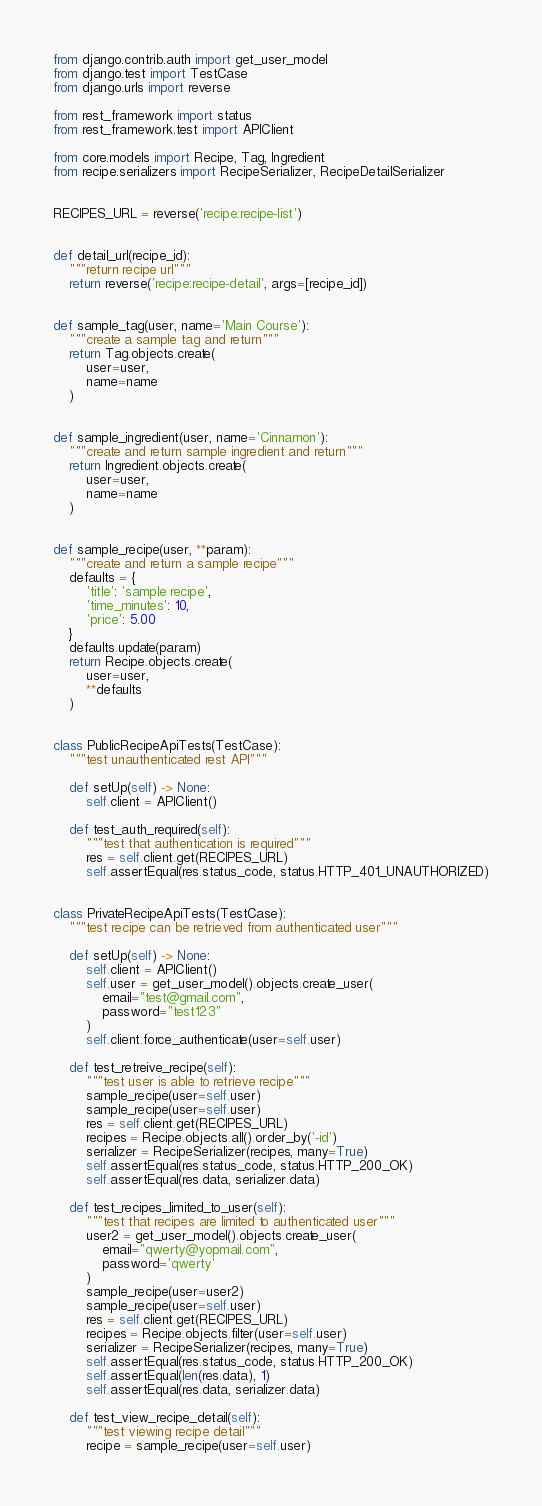<code> <loc_0><loc_0><loc_500><loc_500><_Python_>from django.contrib.auth import get_user_model
from django.test import TestCase
from django.urls import reverse

from rest_framework import status
from rest_framework.test import APIClient

from core.models import Recipe, Tag, Ingredient
from recipe.serializers import RecipeSerializer, RecipeDetailSerializer


RECIPES_URL = reverse('recipe:recipe-list')


def detail_url(recipe_id):
    """return recipe url"""
    return reverse('recipe:recipe-detail', args=[recipe_id])


def sample_tag(user, name='Main Course'):
    """create a sample tag and return"""
    return Tag.objects.create(
        user=user,
        name=name
    )


def sample_ingredient(user, name='Cinnamon'):
    """create and return sample ingredient and return"""
    return Ingredient.objects.create(
        user=user,
        name=name
    )


def sample_recipe(user, **param):
    """create and return a sample recipe"""
    defaults = {
        'title': 'sample recipe',
        'time_minutes': 10,
        'price': 5.00
    }
    defaults.update(param)
    return Recipe.objects.create(
        user=user,
        **defaults
    )


class PublicRecipeApiTests(TestCase):
    """test unauthenticated rest API"""

    def setUp(self) -> None:
        self.client = APIClient()

    def test_auth_required(self):
        """test that authentication is required"""
        res = self.client.get(RECIPES_URL)
        self.assertEqual(res.status_code, status.HTTP_401_UNAUTHORIZED)


class PrivateRecipeApiTests(TestCase):
    """test recipe can be retrieved from authenticated user"""

    def setUp(self) -> None:
        self.client = APIClient()
        self.user = get_user_model().objects.create_user(
            email="test@gmail.com",
            password="test123"
        )
        self.client.force_authenticate(user=self.user)

    def test_retreive_recipe(self):
        """test user is able to retrieve recipe"""
        sample_recipe(user=self.user)
        sample_recipe(user=self.user)
        res = self.client.get(RECIPES_URL)
        recipes = Recipe.objects.all().order_by('-id')
        serializer = RecipeSerializer(recipes, many=True)
        self.assertEqual(res.status_code, status.HTTP_200_OK)
        self.assertEqual(res.data, serializer.data)

    def test_recipes_limited_to_user(self):
        """test that recipes are limited to authenticated user"""
        user2 = get_user_model().objects.create_user(
            email="qwerty@yopmail.com",
            password='qwerty'
        )
        sample_recipe(user=user2)
        sample_recipe(user=self.user)
        res = self.client.get(RECIPES_URL)
        recipes = Recipe.objects.filter(user=self.user)
        serializer = RecipeSerializer(recipes, many=True)
        self.assertEqual(res.status_code, status.HTTP_200_OK)
        self.assertEqual(len(res.data), 1)
        self.assertEqual(res.data, serializer.data)

    def test_view_recipe_detail(self):
        """test viewing recipe detail"""
        recipe = sample_recipe(user=self.user)</code> 